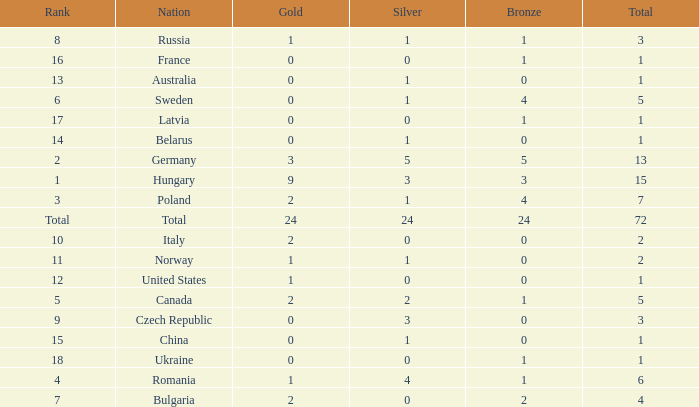What average silver has belarus as the nation, with a total less than 1? None. 